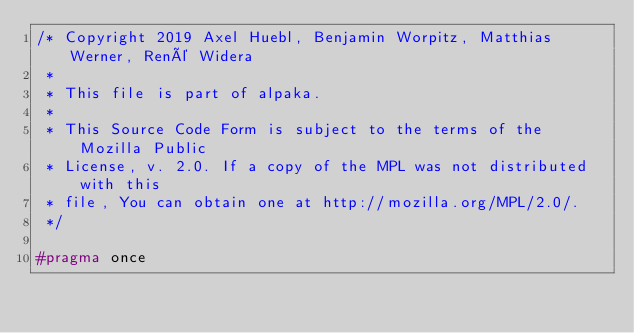<code> <loc_0><loc_0><loc_500><loc_500><_C++_>/* Copyright 2019 Axel Huebl, Benjamin Worpitz, Matthias Werner, René Widera
 *
 * This file is part of alpaka.
 *
 * This Source Code Form is subject to the terms of the Mozilla Public
 * License, v. 2.0. If a copy of the MPL was not distributed with this
 * file, You can obtain one at http://mozilla.org/MPL/2.0/.
 */

#pragma once
</code> 